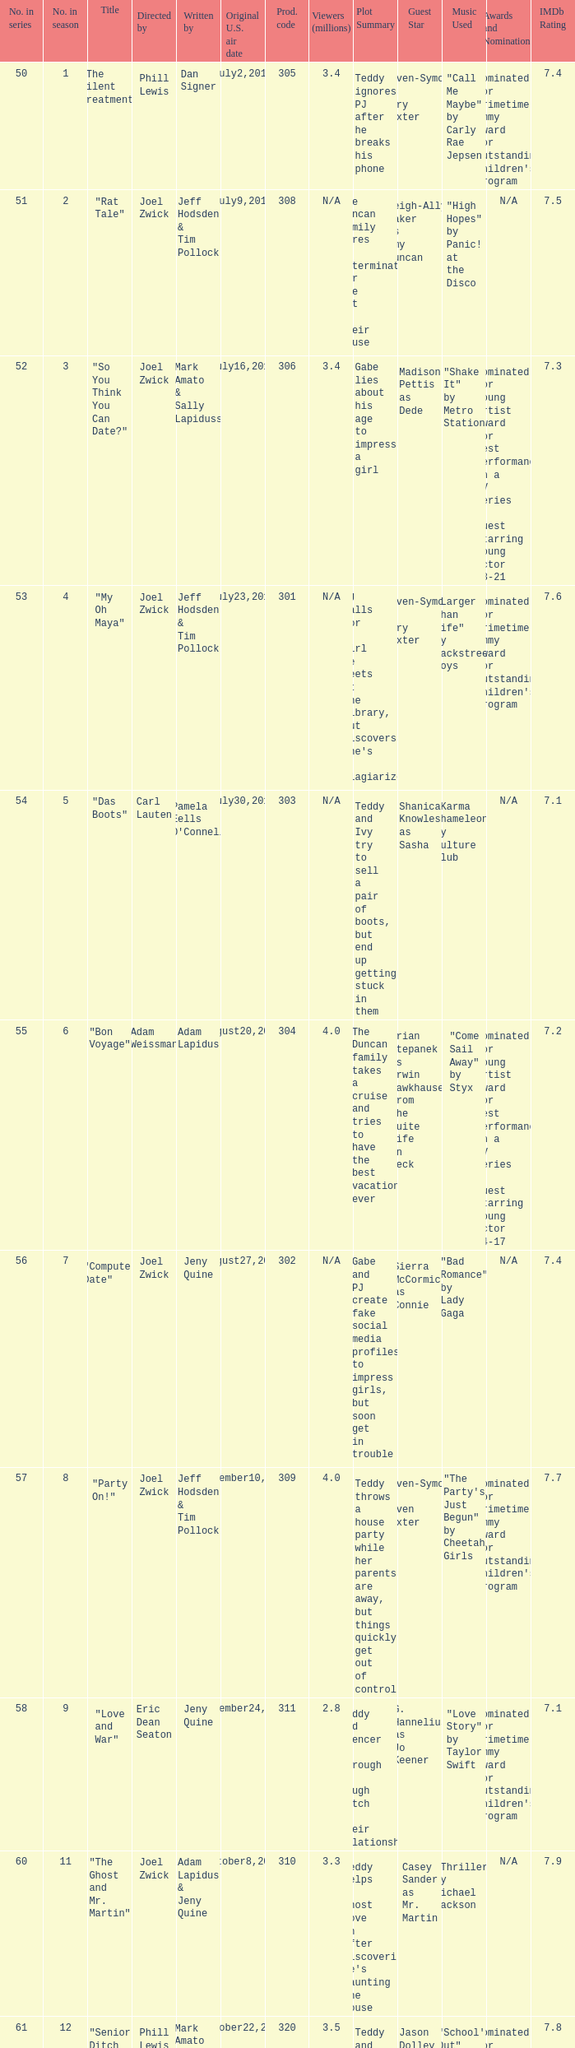Which us broadcast date had January14,2011. 